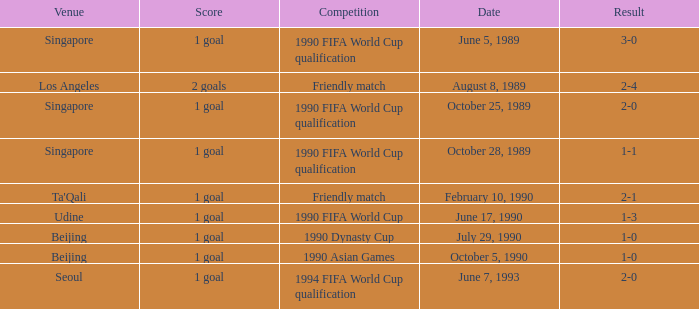What is the score of the match on October 5, 1990? 1 goal. 